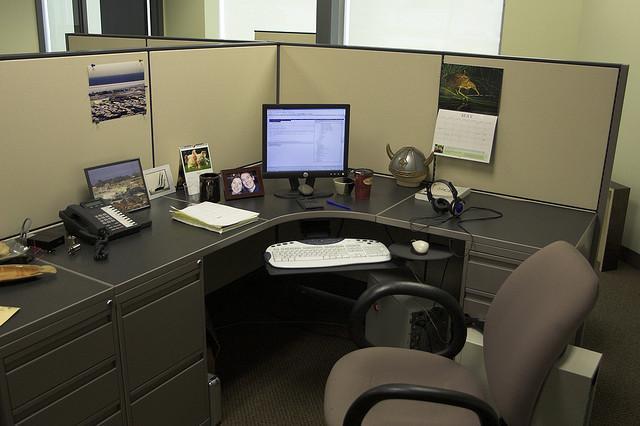How many monitors are on the desk?
Give a very brief answer. 1. How many chairs are there?
Give a very brief answer. 1. 